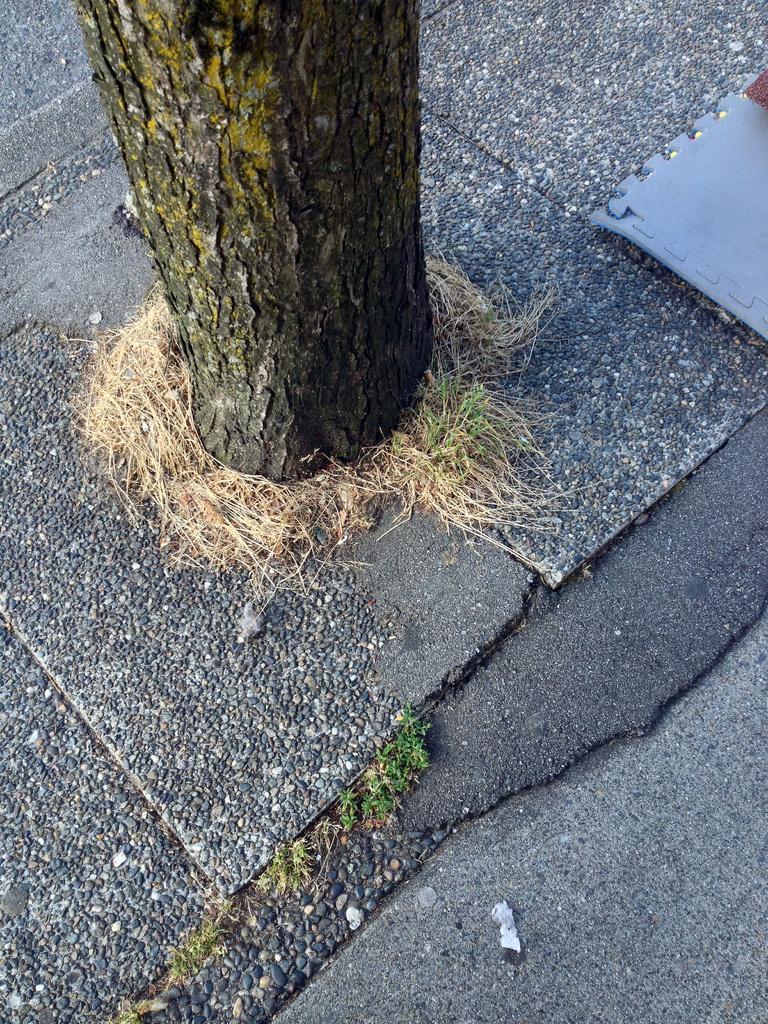Could you give a brief overview of what you see in this image? In this picture we can see a tree, at the bottom there is some grass. 